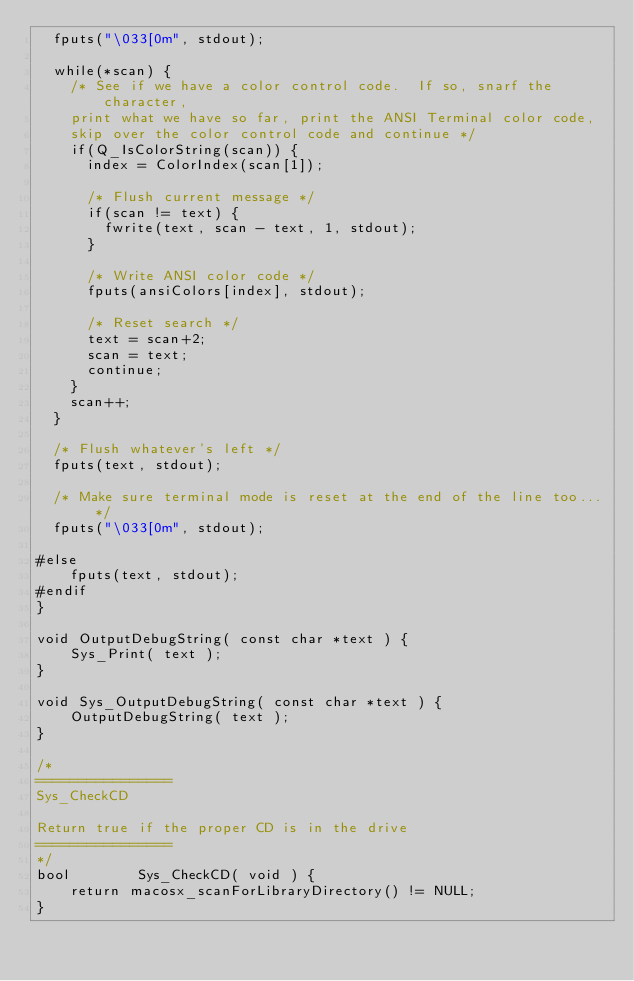Convert code to text. <code><loc_0><loc_0><loc_500><loc_500><_ObjectiveC_>	fputs("\033[0m", stdout);
	
	while(*scan) {
		/* See if we have a color control code.  If so, snarf the character, 
		print what we have so far, print the ANSI Terminal color code,
		skip over the color control code and continue */
		if(Q_IsColorString(scan)) {
			index = ColorIndex(scan[1]);
			
			/* Flush current message */
			if(scan != text) {
				fwrite(text, scan - text, 1, stdout);
			}
			
			/* Write ANSI color code */
			fputs(ansiColors[index], stdout);
			
			/* Reset search */
			text = scan+2;
			scan = text;
			continue;			
		}
		scan++;
	}

	/* Flush whatever's left */
	fputs(text, stdout);

	/* Make sure terminal mode is reset at the end of the line too... */
	fputs("\033[0m", stdout);

#else
    fputs(text, stdout);
#endif	
}

void OutputDebugString( const char *text ) {
    Sys_Print( text );
}

void Sys_OutputDebugString( const char *text ) {
    OutputDebugString( text );
}

/*
================
Sys_CheckCD

Return true if the proper CD is in the drive
================
*/
bool        Sys_CheckCD( void ) {
    return macosx_scanForLibraryDirectory() != NULL;
}
</code> 